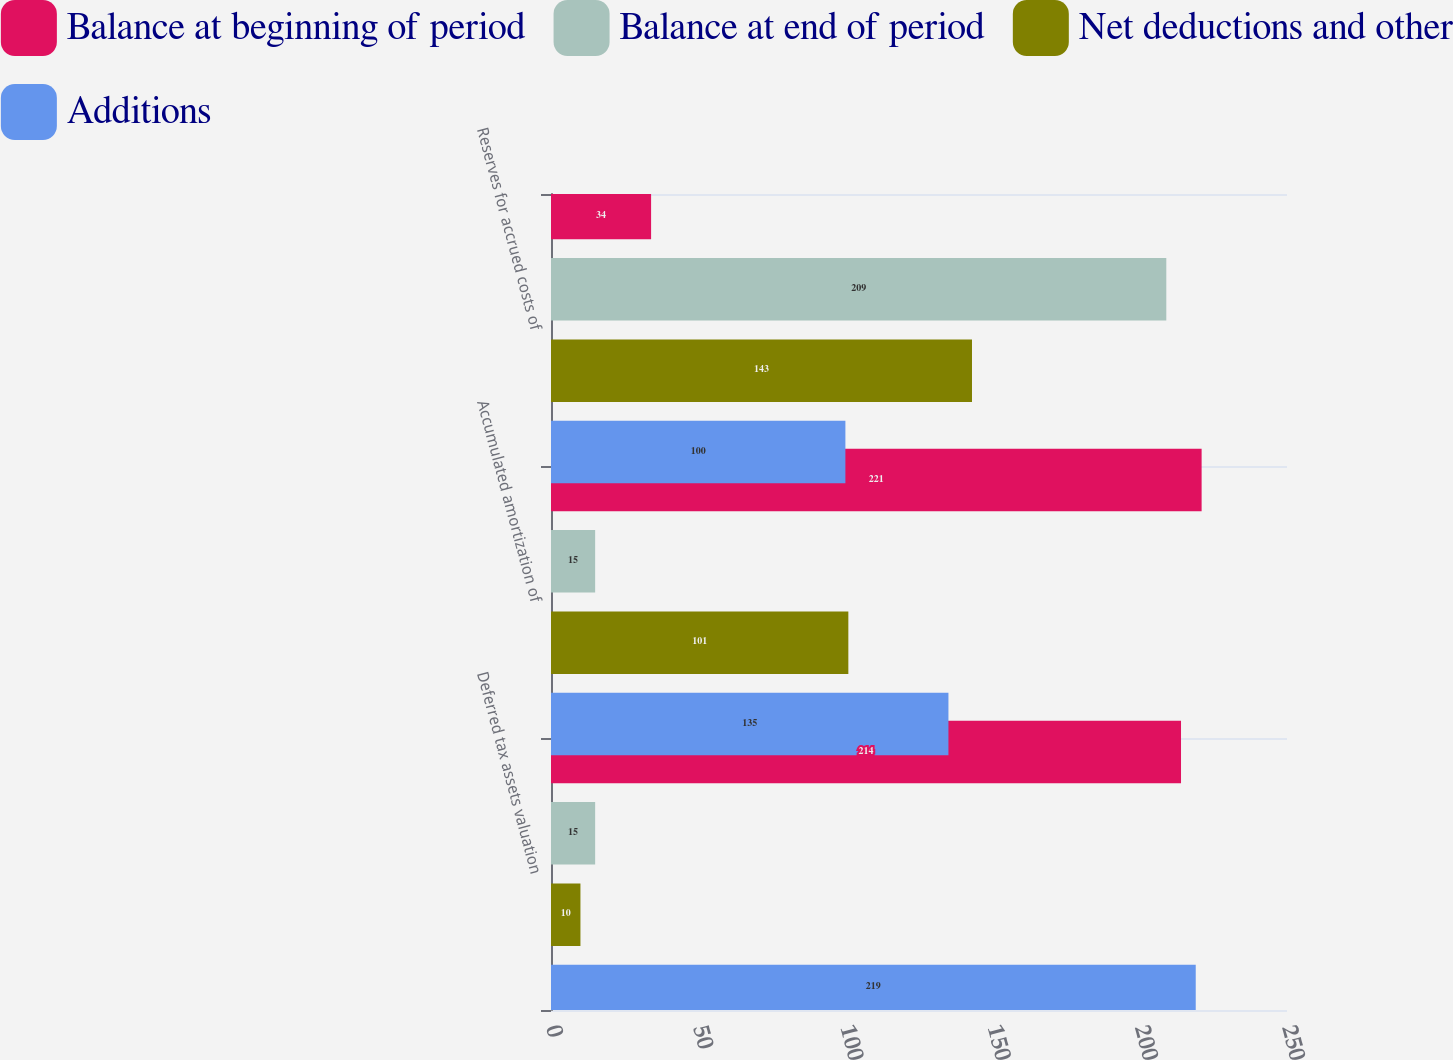Convert chart. <chart><loc_0><loc_0><loc_500><loc_500><stacked_bar_chart><ecel><fcel>Deferred tax assets valuation<fcel>Accumulated amortization of<fcel>Reserves for accrued costs of<nl><fcel>Balance at beginning of period<fcel>214<fcel>221<fcel>34<nl><fcel>Balance at end of period<fcel>15<fcel>15<fcel>209<nl><fcel>Net deductions and other<fcel>10<fcel>101<fcel>143<nl><fcel>Additions<fcel>219<fcel>135<fcel>100<nl></chart> 